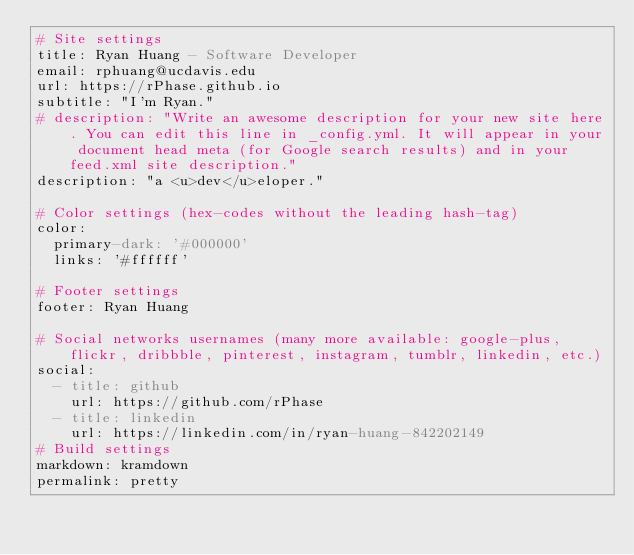Convert code to text. <code><loc_0><loc_0><loc_500><loc_500><_YAML_># Site settings
title: Ryan Huang - Software Developer
email: rphuang@ucdavis.edu
url: https://rPhase.github.io
subtitle: "I'm Ryan."
# description: "Write an awesome description for your new site here. You can edit this line in _config.yml. It will appear in your document head meta (for Google search results) and in your feed.xml site description."
description: "a <u>dev</u>eloper."

# Color settings (hex-codes without the leading hash-tag)
color:
  primary-dark: '#000000'
  links: '#ffffff'

# Footer settings
footer: Ryan Huang

# Social networks usernames (many more available: google-plus, flickr, dribbble, pinterest, instagram, tumblr, linkedin, etc.)
social:
  - title: github
    url: https://github.com/rPhase
  - title: linkedin
    url: https://linkedin.com/in/ryan-huang-842202149
# Build settings
markdown: kramdown
permalink: pretty
</code> 